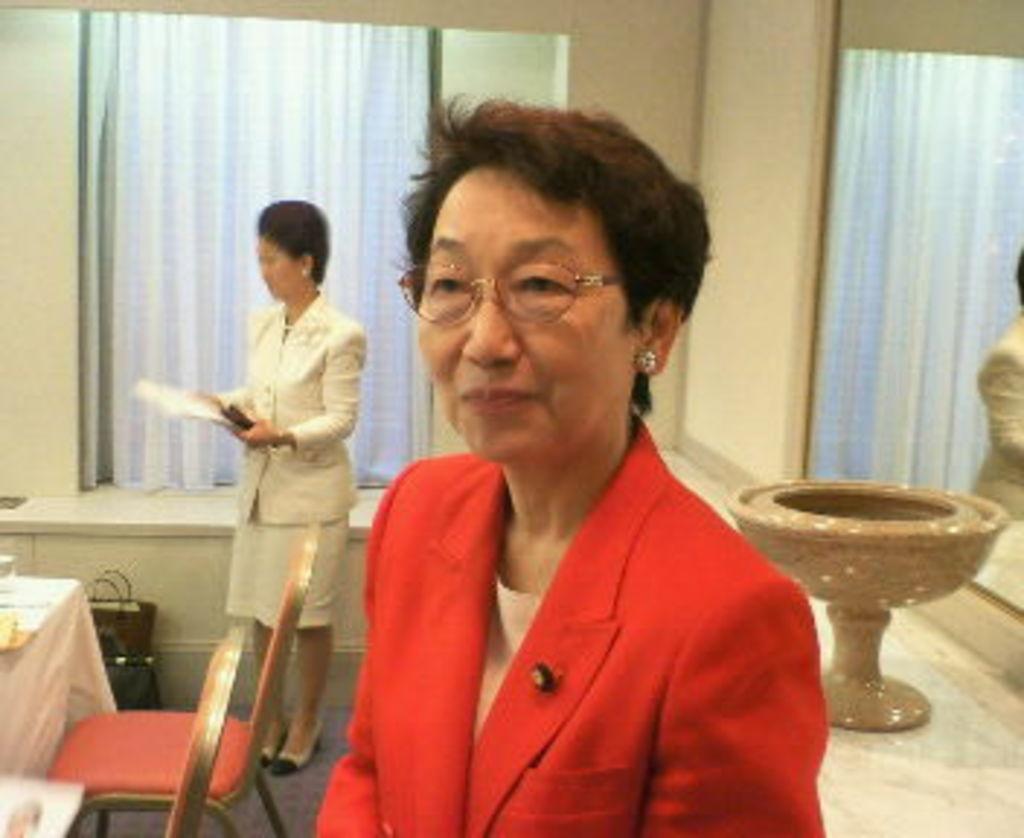Please provide a concise description of this image. A woman is posing to camera with a red color suit. There are some chairs,table and woman in the background. 